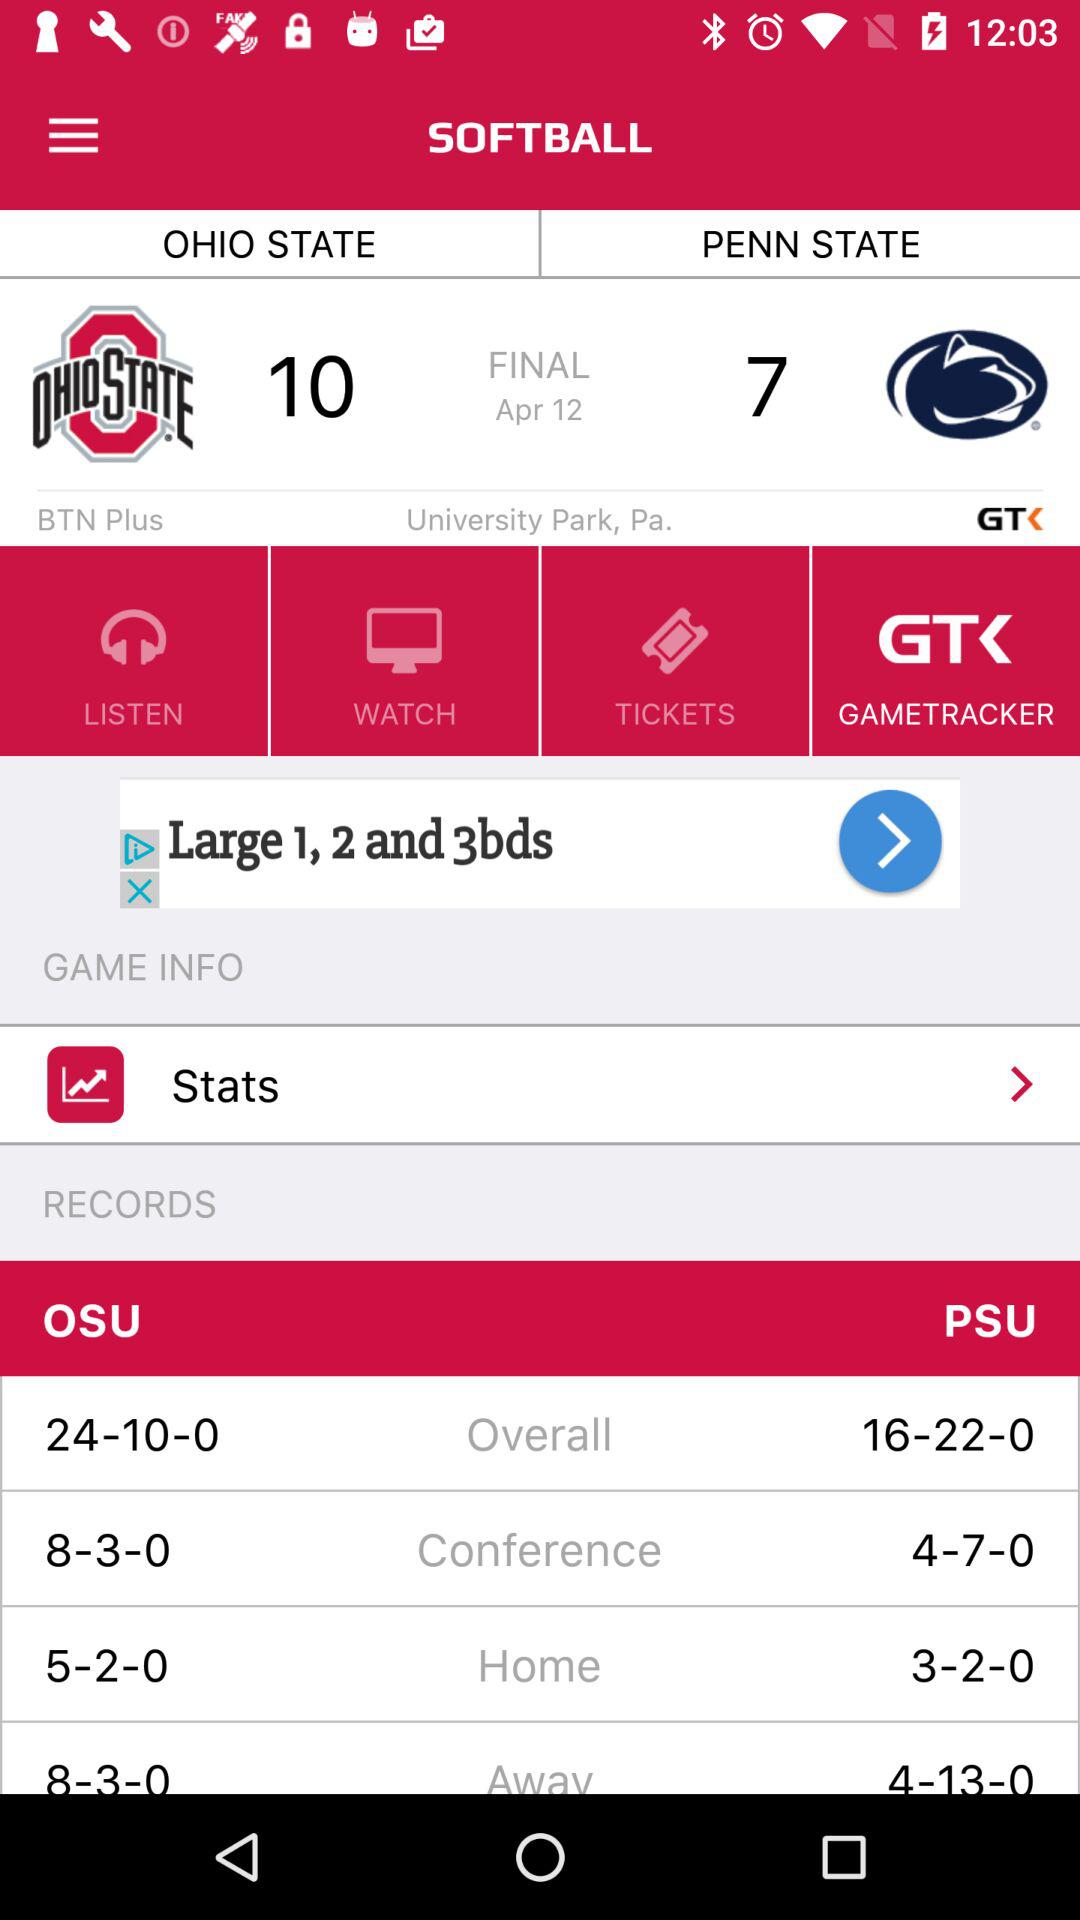What is the score of "OHIO STATE" in the final set? The score of "OHIO STATE" in the final set is 10. 